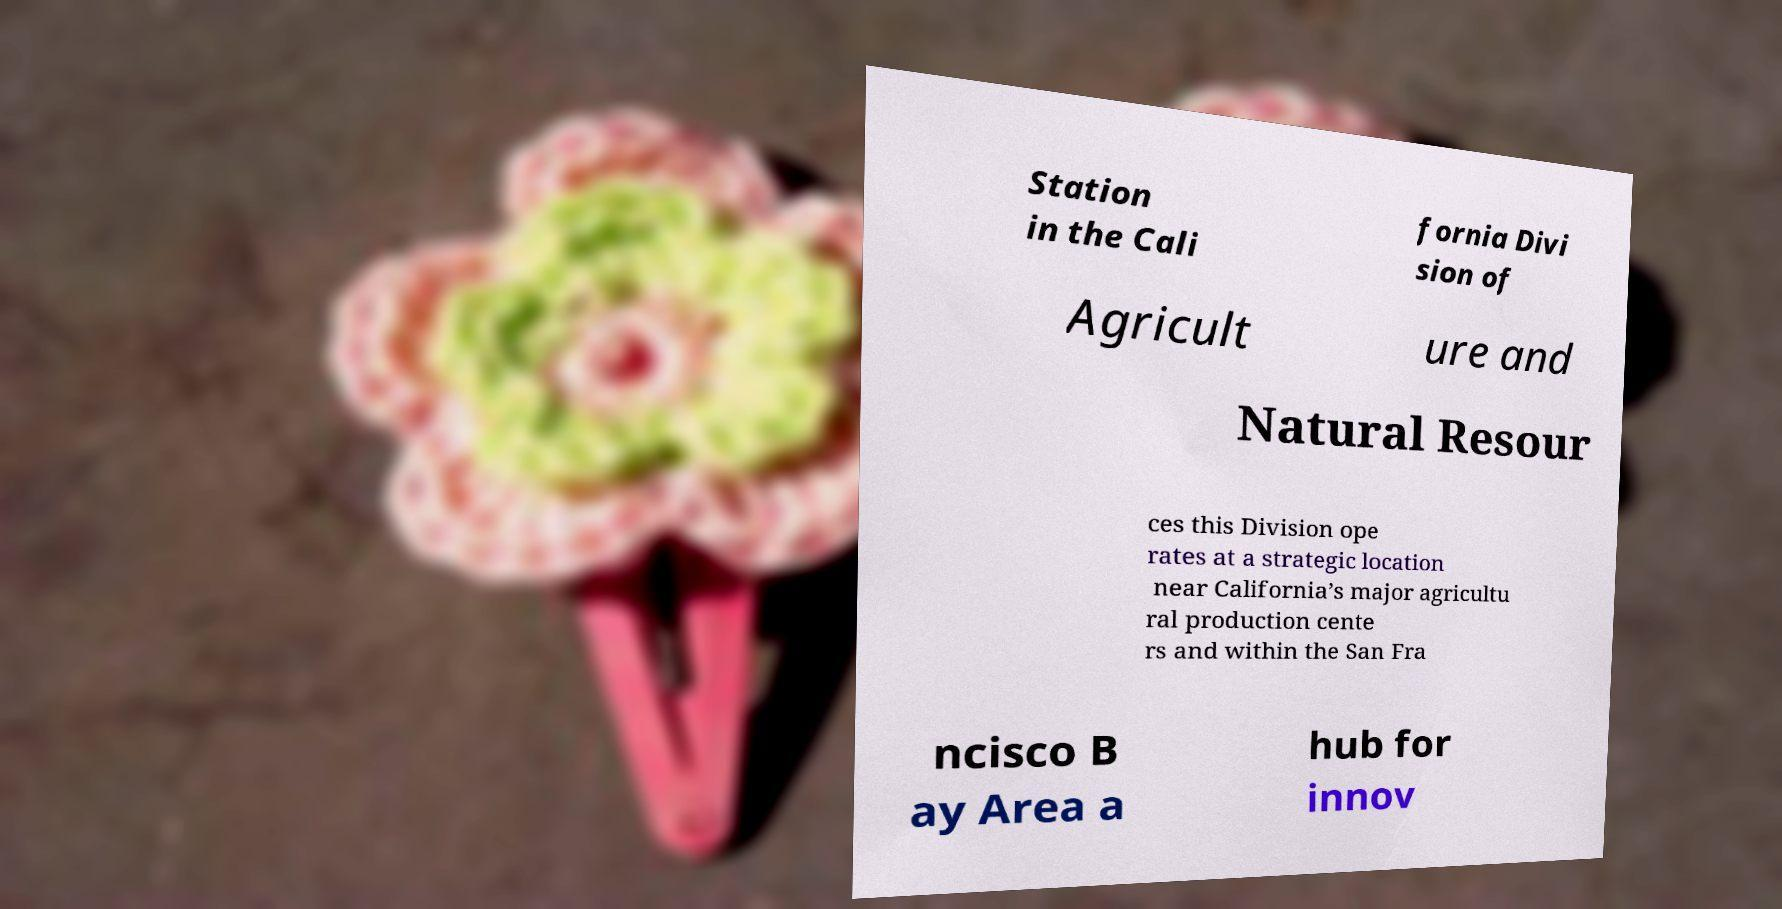Can you accurately transcribe the text from the provided image for me? Station in the Cali fornia Divi sion of Agricult ure and Natural Resour ces this Division ope rates at a strategic location near California’s major agricultu ral production cente rs and within the San Fra ncisco B ay Area a hub for innov 